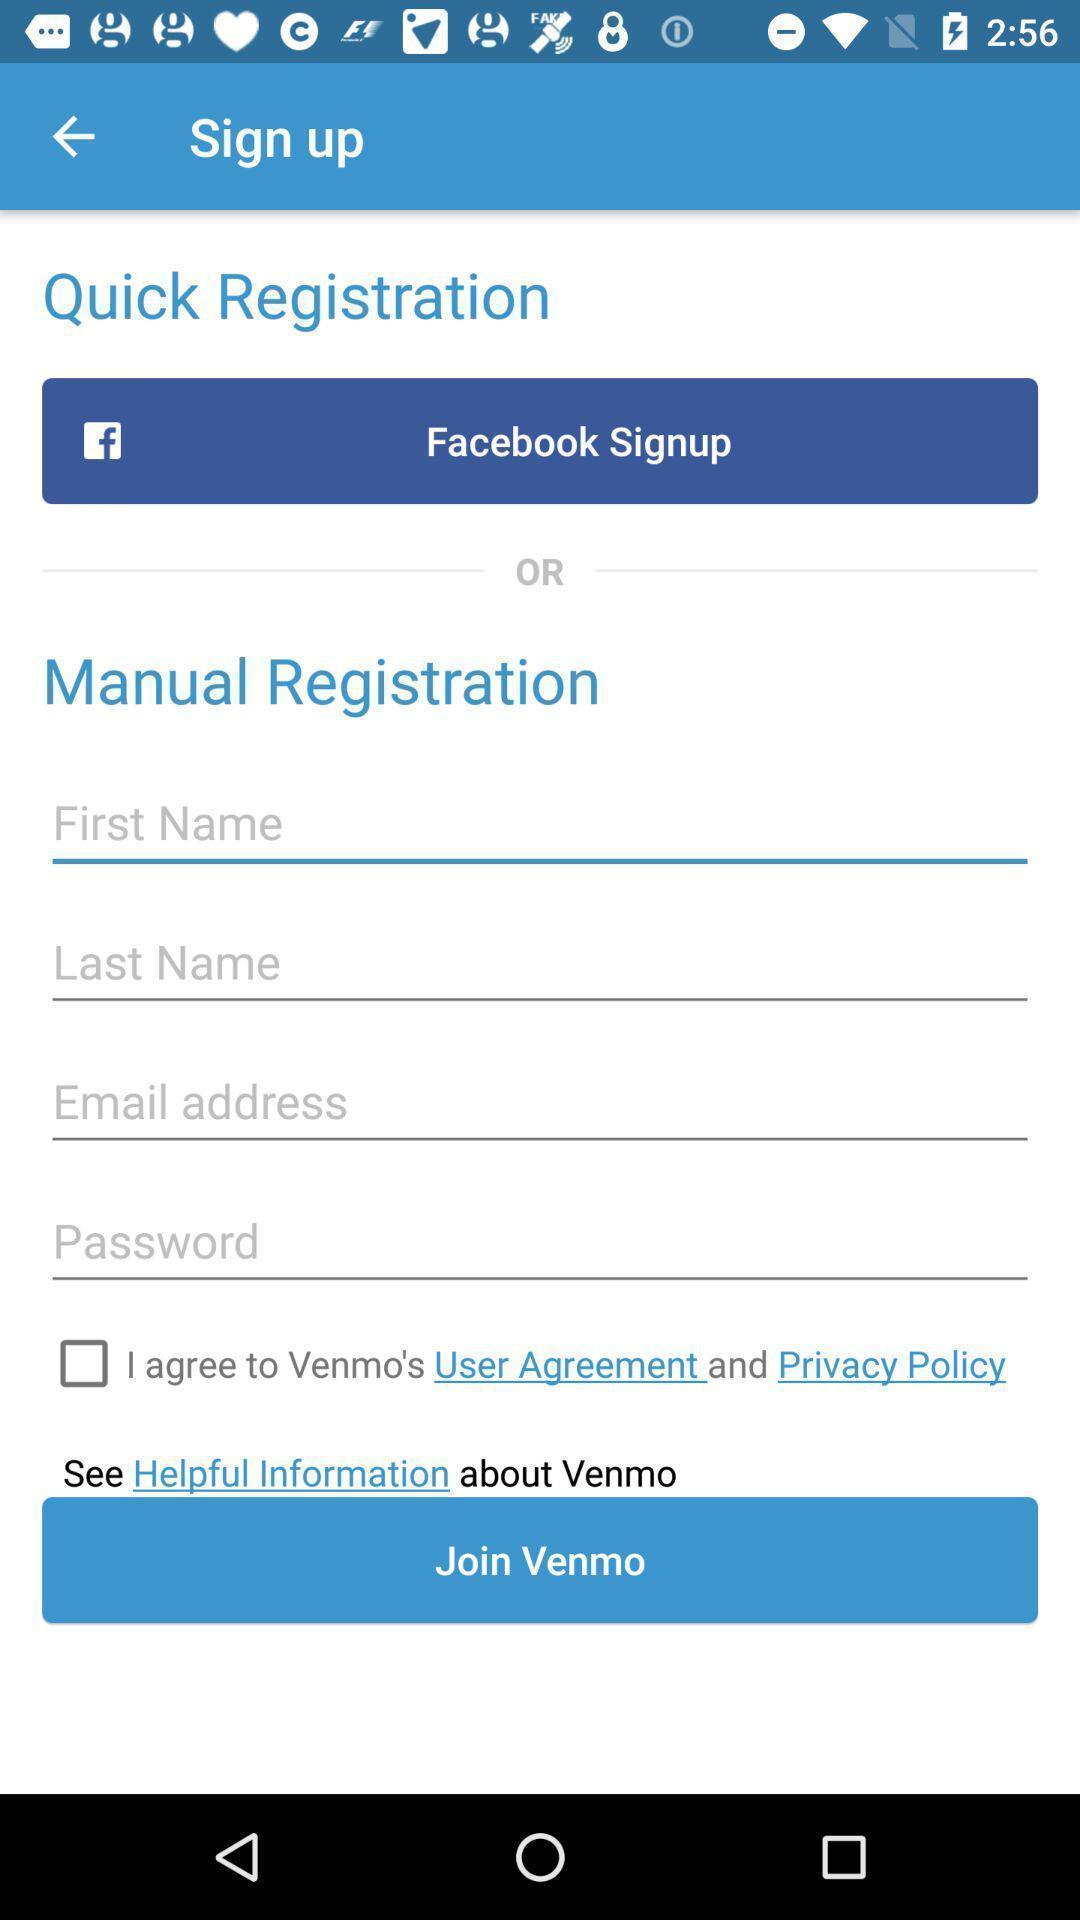Describe this image in words. Sign up page. 